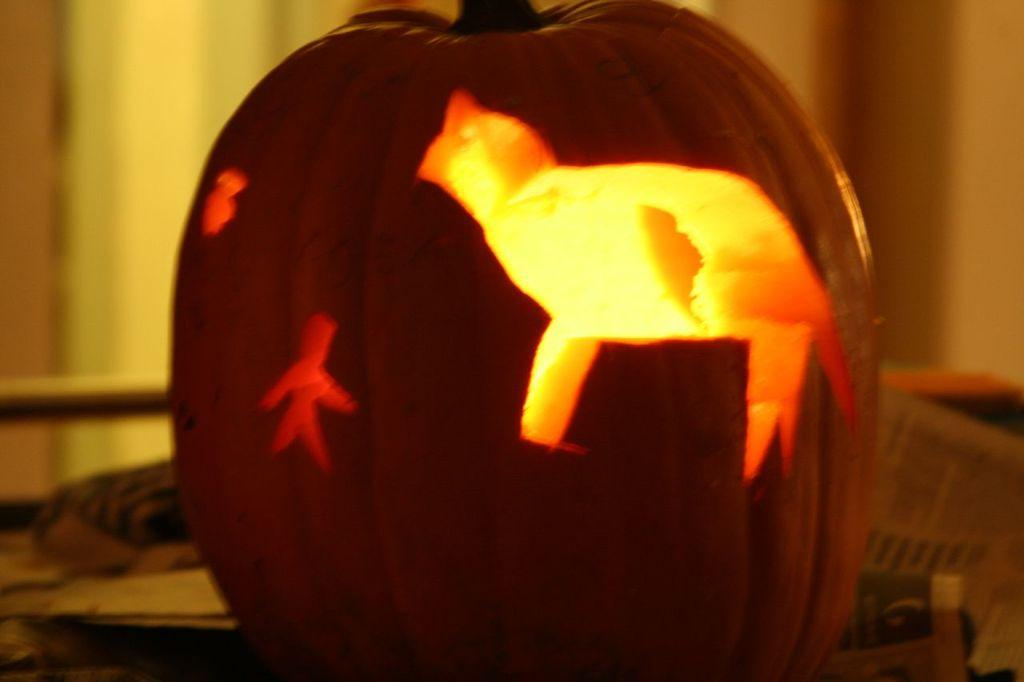What is the main object in the image? There is a pumpkin in the image. What color is the pumpkin? The pumpkin is orange in color. Is there any indication of a light source within the pumpkin? Yes, there is light visible inside the pumpkin. What can be seen in the background of the image? There are papers and other blurry objects in the background of the image. Can you tell me how many horses are present in the image? There are no horses present in the image; it features a pumpkin with light inside it and papers in the background. 